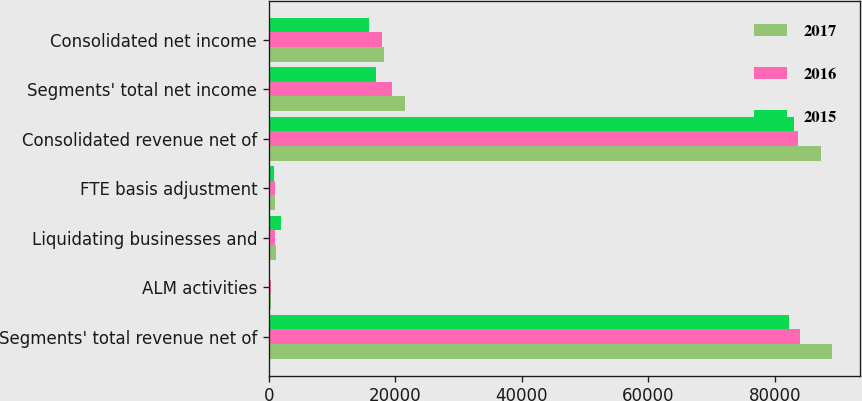Convert chart to OTSL. <chart><loc_0><loc_0><loc_500><loc_500><stacked_bar_chart><ecel><fcel>Segments' total revenue net of<fcel>ALM activities<fcel>Liquidating businesses and<fcel>FTE basis adjustment<fcel>Consolidated revenue net of<fcel>Segments' total net income<fcel>Consolidated net income<nl><fcel>2017<fcel>89061<fcel>312<fcel>1096<fcel>925<fcel>87352<fcel>21541<fcel>18232<nl><fcel>2016<fcel>83916<fcel>300<fcel>985<fcel>900<fcel>83701<fcel>19494<fcel>17822<nl><fcel>2015<fcel>82187<fcel>208<fcel>1875<fcel>889<fcel>82965<fcel>16981<fcel>15910<nl></chart> 